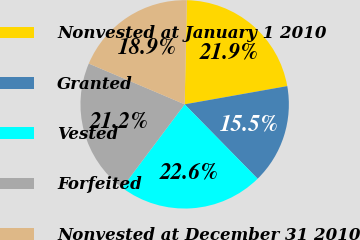Convert chart. <chart><loc_0><loc_0><loc_500><loc_500><pie_chart><fcel>Nonvested at January 1 2010<fcel>Granted<fcel>Vested<fcel>Forfeited<fcel>Nonvested at December 31 2010<nl><fcel>21.87%<fcel>15.46%<fcel>22.58%<fcel>21.16%<fcel>18.93%<nl></chart> 